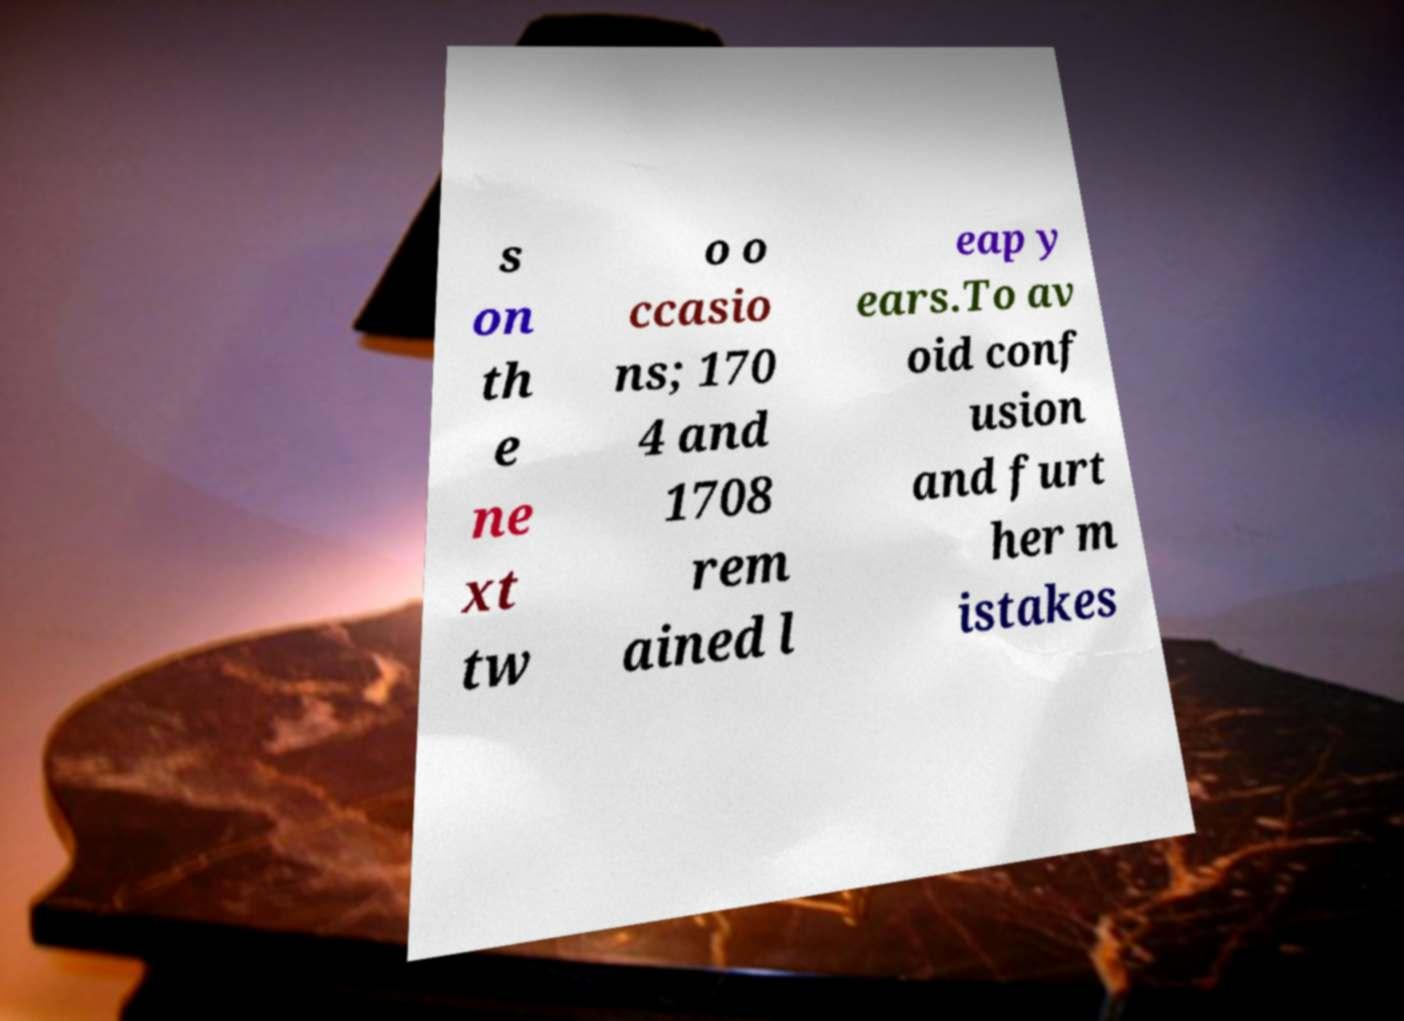What messages or text are displayed in this image? I need them in a readable, typed format. s on th e ne xt tw o o ccasio ns; 170 4 and 1708 rem ained l eap y ears.To av oid conf usion and furt her m istakes 